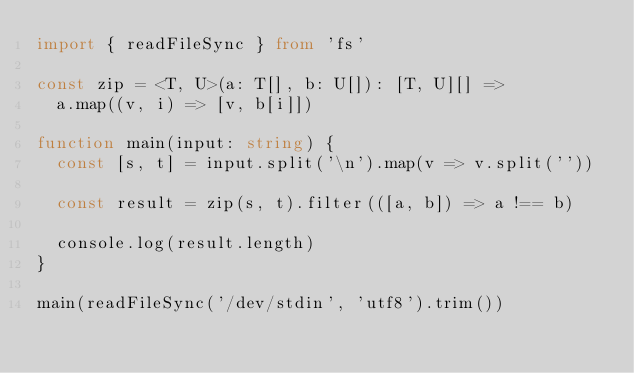<code> <loc_0><loc_0><loc_500><loc_500><_TypeScript_>import { readFileSync } from 'fs'

const zip = <T, U>(a: T[], b: U[]): [T, U][] =>
  a.map((v, i) => [v, b[i]])

function main(input: string) {
  const [s, t] = input.split('\n').map(v => v.split(''))

  const result = zip(s, t).filter(([a, b]) => a !== b)

  console.log(result.length)
}

main(readFileSync('/dev/stdin', 'utf8').trim())
</code> 